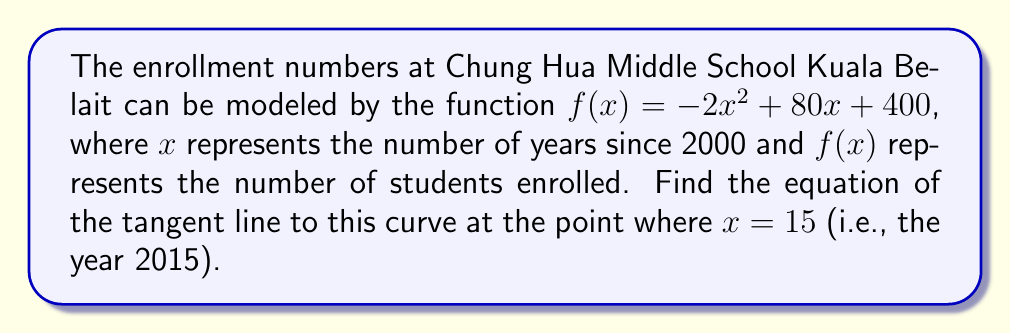Solve this math problem. To find the equation of the tangent line, we need to follow these steps:

1) First, we need to find the point of tangency. We can do this by calculating $f(15)$:
   $f(15) = -2(15)^2 + 80(15) + 400$
   $= -2(225) + 1200 + 400$
   $= -450 + 1600$
   $= 1150$

   So, the point of tangency is $(15, 1150)$.

2) Next, we need to find the slope of the tangent line. This is equal to the derivative of $f(x)$ at $x = 15$. Let's calculate $f'(x)$:
   $f'(x) = -4x + 80$

3) Now we can calculate $f'(15)$:
   $f'(15) = -4(15) + 80 = -60 + 80 = 20$

4) We now have a point $(15, 1150)$ and a slope of 20. We can use the point-slope form of a line to write our equation:
   $y - y_1 = m(x - x_1)$
   $y - 1150 = 20(x - 15)$

5) If we want to convert this to slope-intercept form, we can expand:
   $y = 20(x - 15) + 1150$
   $y = 20x - 300 + 1150$
   $y = 20x + 850$

Therefore, the equation of the tangent line is $y = 20x + 850$.
Answer: $y = 20x + 850$ 